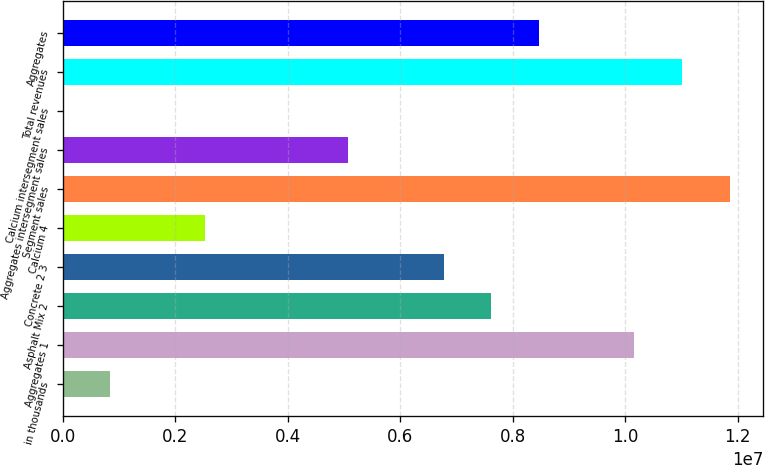<chart> <loc_0><loc_0><loc_500><loc_500><bar_chart><fcel>in thousands<fcel>Aggregates 1<fcel>Asphalt Mix 2<fcel>Concrete 2 3<fcel>Calcium 4<fcel>Segment sales<fcel>Aggregates intersegment sales<fcel>Calcium intersegment sales<fcel>Total revenues<fcel>Aggregates<nl><fcel>847150<fcel>1.01658e+07<fcel>7.62433e+06<fcel>6.77718e+06<fcel>2.54144e+06<fcel>1.18601e+07<fcel>5.08289e+06<fcel>2.85<fcel>1.10129e+07<fcel>8.47147e+06<nl></chart> 